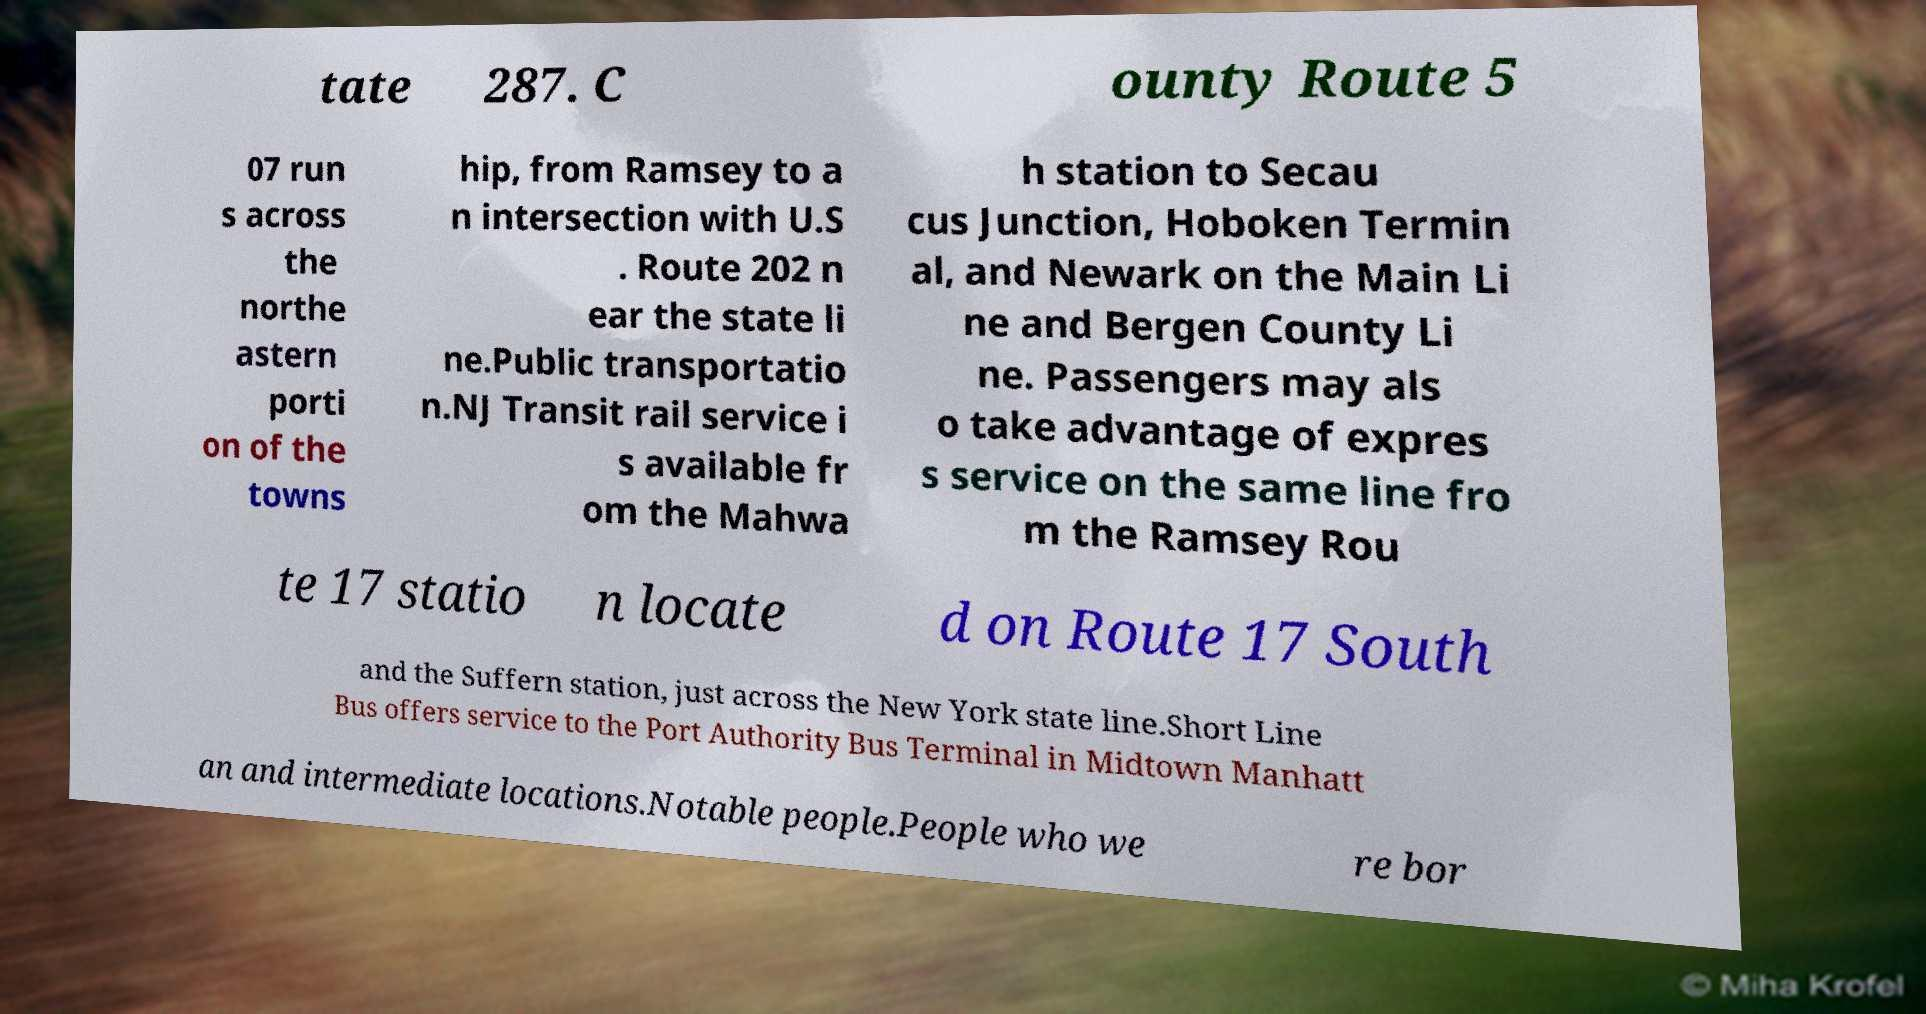I need the written content from this picture converted into text. Can you do that? tate 287. C ounty Route 5 07 run s across the northe astern porti on of the towns hip, from Ramsey to a n intersection with U.S . Route 202 n ear the state li ne.Public transportatio n.NJ Transit rail service i s available fr om the Mahwa h station to Secau cus Junction, Hoboken Termin al, and Newark on the Main Li ne and Bergen County Li ne. Passengers may als o take advantage of expres s service on the same line fro m the Ramsey Rou te 17 statio n locate d on Route 17 South and the Suffern station, just across the New York state line.Short Line Bus offers service to the Port Authority Bus Terminal in Midtown Manhatt an and intermediate locations.Notable people.People who we re bor 